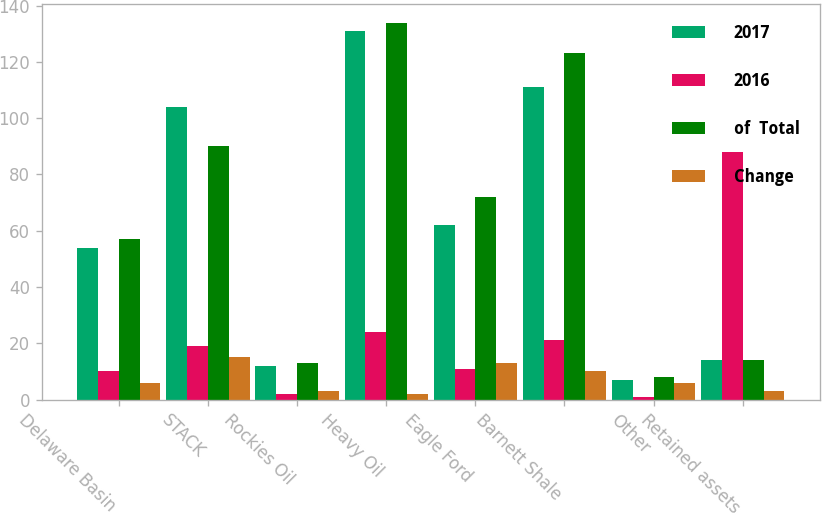Convert chart. <chart><loc_0><loc_0><loc_500><loc_500><stacked_bar_chart><ecel><fcel>Delaware Basin<fcel>STACK<fcel>Rockies Oil<fcel>Heavy Oil<fcel>Eagle Ford<fcel>Barnett Shale<fcel>Other<fcel>Retained assets<nl><fcel>2017<fcel>54<fcel>104<fcel>12<fcel>131<fcel>62<fcel>111<fcel>7<fcel>14<nl><fcel>2016<fcel>10<fcel>19<fcel>2<fcel>24<fcel>11<fcel>21<fcel>1<fcel>88<nl><fcel>of  Total<fcel>57<fcel>90<fcel>13<fcel>134<fcel>72<fcel>123<fcel>8<fcel>14<nl><fcel>Change<fcel>6<fcel>15<fcel>3<fcel>2<fcel>13<fcel>10<fcel>6<fcel>3<nl></chart> 